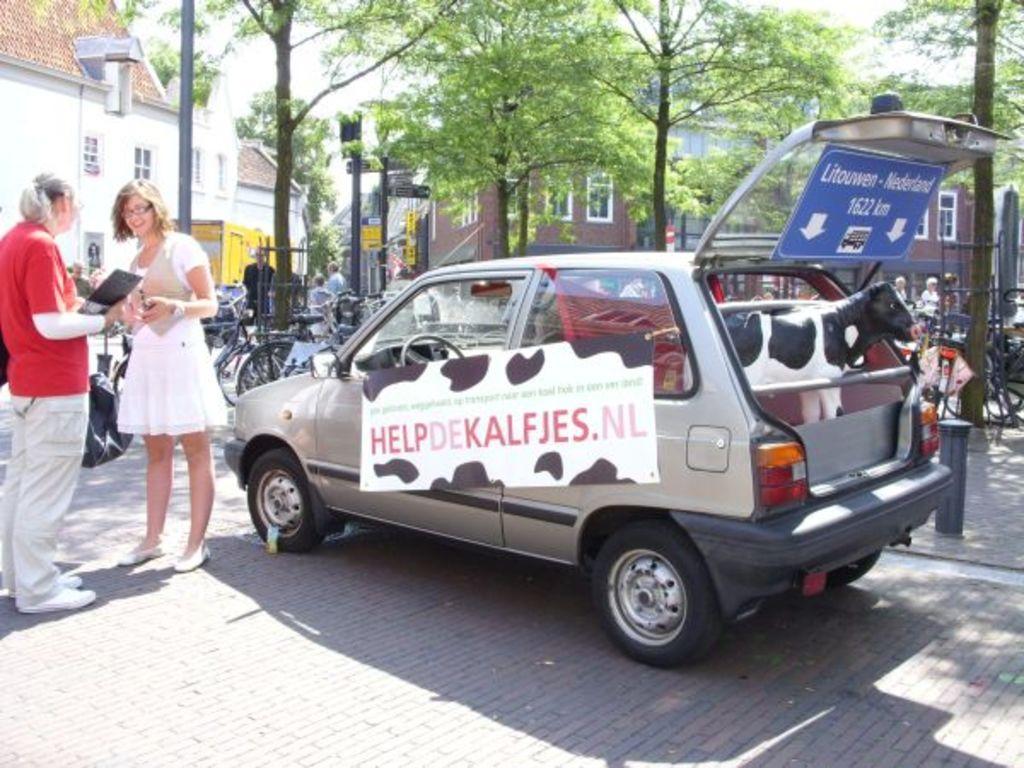Can you describe this image briefly? In this image we can see few buildings and they are having many windows. There are few directional board in the image. There are many trees in the image. There are many vehicles in the image. There is an animal in the car. There are few advertising boards in the image. There are few people in the image. 